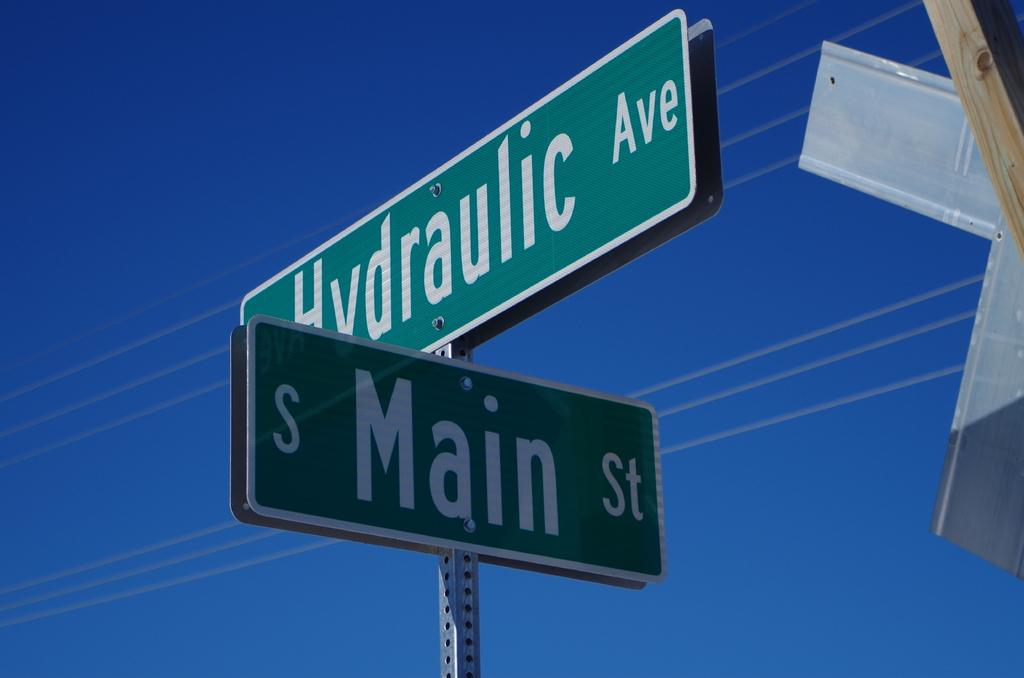<image>
Create a compact narrative representing the image presented. Blue sky on the corner of Main St. and Hydraulic Ave. 